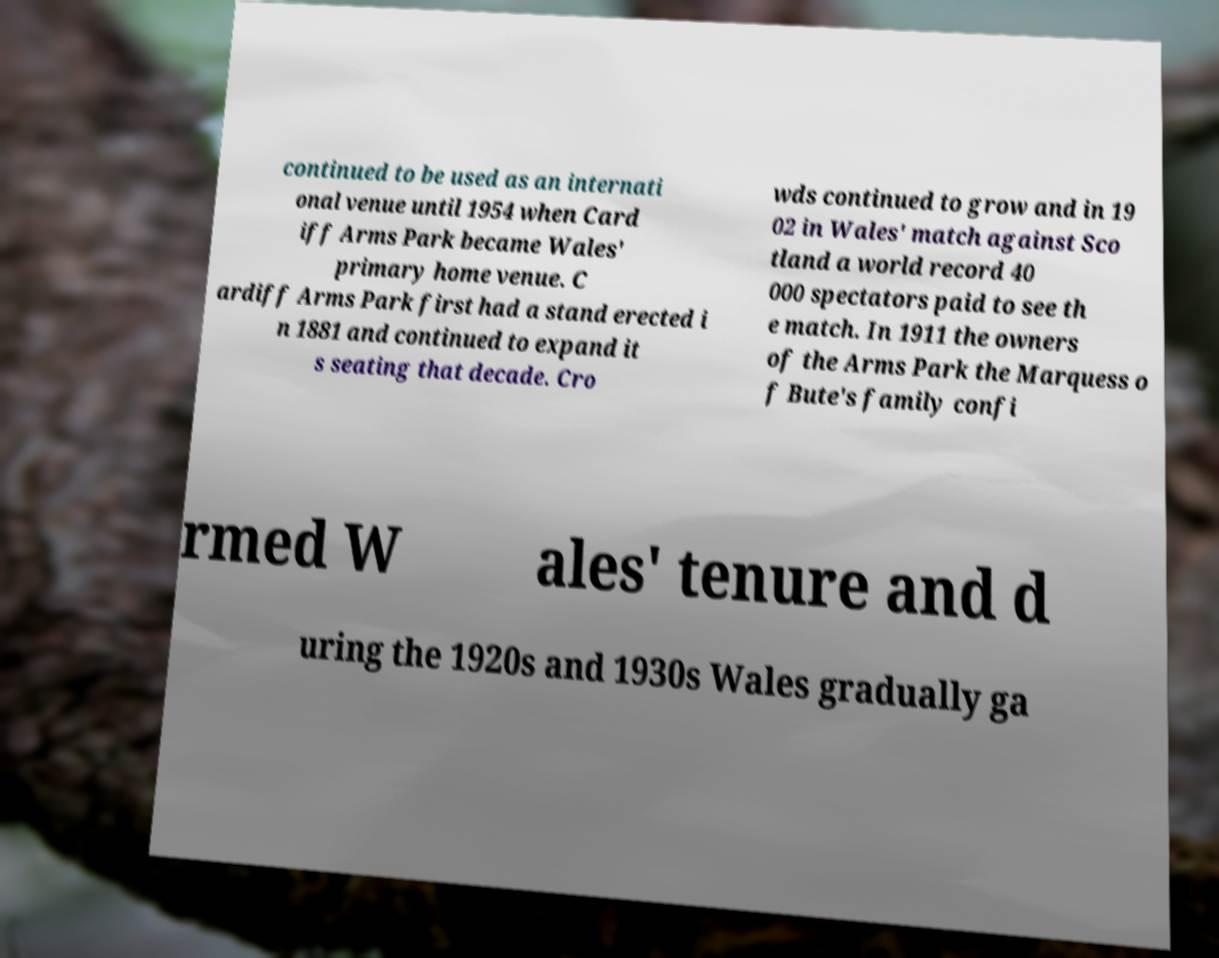Please identify and transcribe the text found in this image. continued to be used as an internati onal venue until 1954 when Card iff Arms Park became Wales' primary home venue. C ardiff Arms Park first had a stand erected i n 1881 and continued to expand it s seating that decade. Cro wds continued to grow and in 19 02 in Wales' match against Sco tland a world record 40 000 spectators paid to see th e match. In 1911 the owners of the Arms Park the Marquess o f Bute's family confi rmed W ales' tenure and d uring the 1920s and 1930s Wales gradually ga 